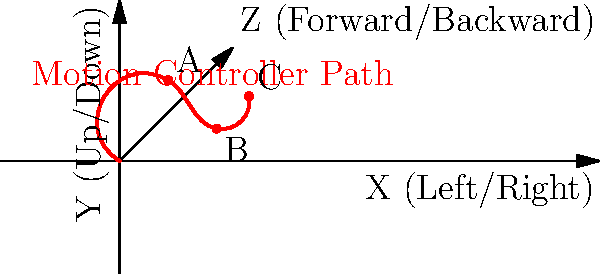In the given 3D coordinate system representing motion controls in gaming, points A, B, and C show the trajectory of a controller movement. If point B represents the controller at its lowest position, what would be the most likely in-game action associated with this movement, assuming a typical motion-controlled sports game? Let's analyze the motion controller path step-by-step:

1. The path starts near the origin and moves upward and slightly forward to point A.
2. From point A, it moves downward and further forward to point B, which is the lowest point on the path.
3. Finally, it moves upward and forward again to point C.

This motion resembles a swinging action, where:
- The initial upward movement (to point A) could be the backswing or preparation.
- The downward movement to the lowest point (B) represents the main part of the swing.
- The final upward movement (to point C) is the follow-through.

In a typical motion-controlled sports game, this kind of swinging motion is most commonly associated with actions like:
- Swinging a golf club
- Swinging a tennis racket
- Throwing a bowling ball

Among these, the golf swing is the most likely candidate because:
1. It typically has a more pronounced vertical component compared to tennis or bowling.
2. The lowest point of the swing (B) in golf is crucial, as it's where the club head should ideally make contact with the ball.
3. The follow-through in golf (represented by the movement to point C) is an essential part of the swing mechanics.

While this motion could potentially represent other actions, given the context of a "typical motion-controlled sports game," a golf swing is the most probable interpretation of this movement pattern.
Answer: Golf swing 